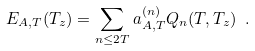<formula> <loc_0><loc_0><loc_500><loc_500>E _ { A , T } ( T _ { z } ) = \sum _ { n \leq 2 T } a ^ { ( n ) } _ { A , T } Q _ { n } ( T , T _ { z } ) \ .</formula> 